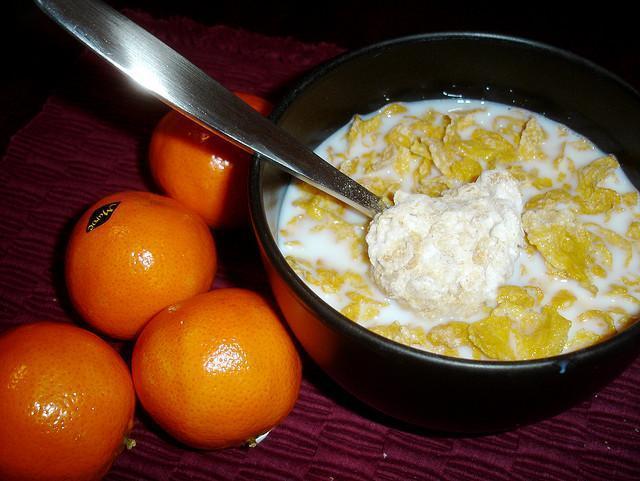How many oranges are there?
Give a very brief answer. 4. How many oranges can be seen?
Give a very brief answer. 4. 